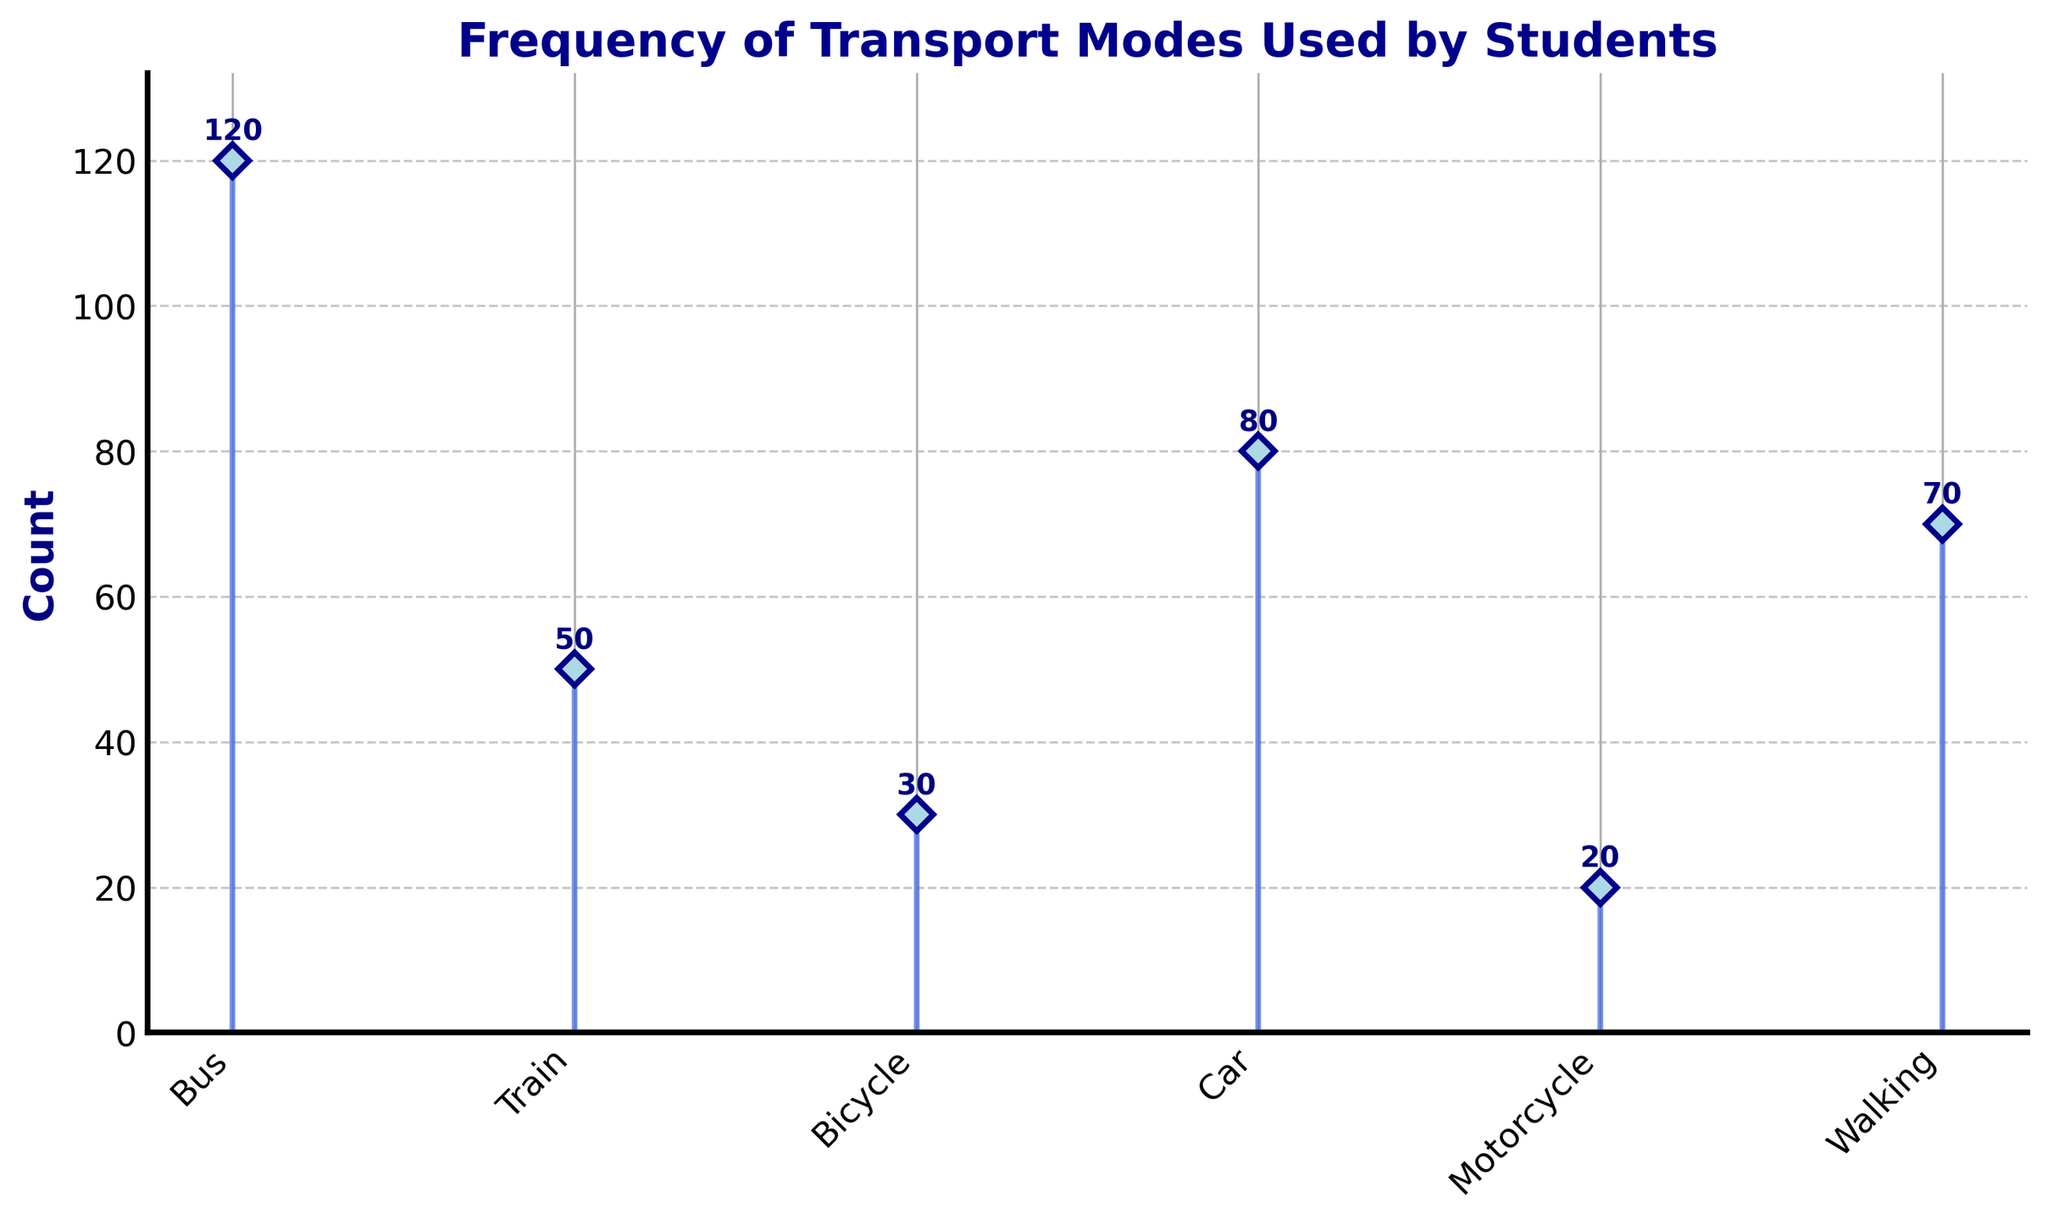What's the title of the figure? The title is located at the top of the plot and provides a summary of what the plot represents.
Answer: Frequency of Transport Modes Used by Students What is the mode of transport with the highest count? By observing the heights of the markers on the stem plot, we can see which mode has the tallest marker.
Answer: Bus What mode of transport has a count of 20? Look at the annotations above each marker to identify the one with the number 20.
Answer: Motorcycle How many total modes of transport are displayed in the figure? Count the number of different modes listed on the x-axis.
Answer: 6 What is the total count of all transport modes combined? Sum up the count values annotated above each mode's marker (120 + 50 + 30 + 80 + 20 + 70).
Answer: 370 Which mode of transport has a greater count, Car or Bicycle? Compare the counts annotated above the markers for Car and Bicycle.
Answer: Car What is the average count of all the transport modes? Calculate the total count (370) and then divide by the number of modes (6).
Answer: 61.67 What is the difference in the count between Bus and Train? Subtract the count for Train from the count for Bus (120 - 50).
Answer: 70 Which mode of transport has the second-highest count? Identify the markers and their counts, and find the mode with the second tallest marker.
Answer: Car If Walking and Bicycle were combined into a single mode, what would be the new count? Add the counts for Walking and Bicycle (70 + 30).
Answer: 100 